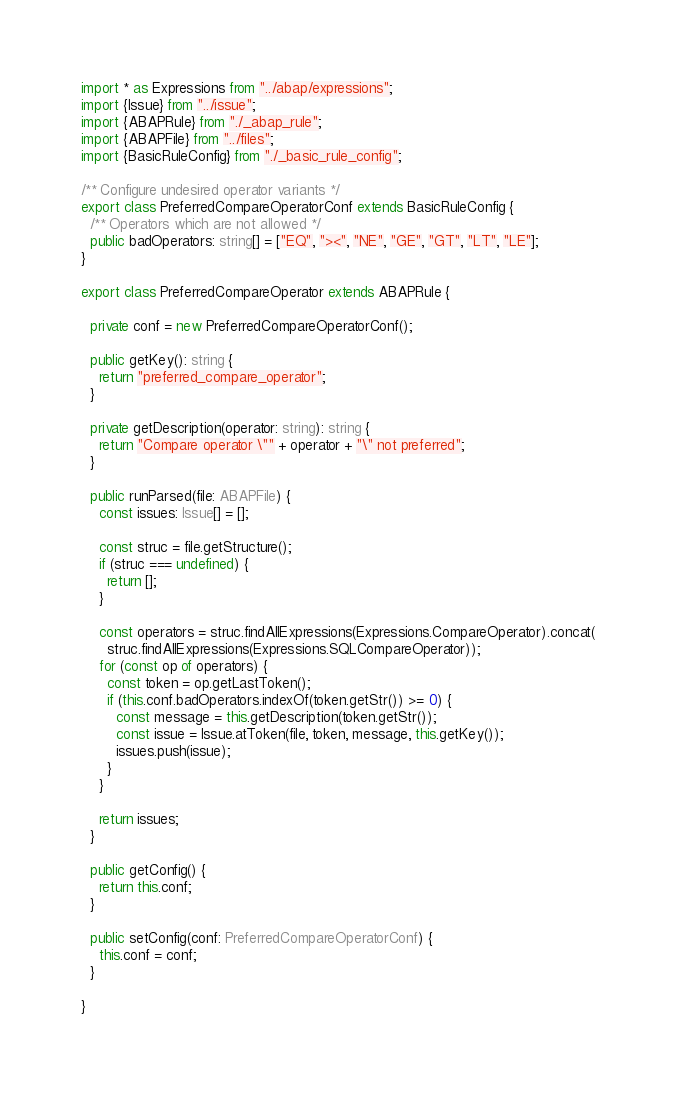Convert code to text. <code><loc_0><loc_0><loc_500><loc_500><_TypeScript_>import * as Expressions from "../abap/expressions";
import {Issue} from "../issue";
import {ABAPRule} from "./_abap_rule";
import {ABAPFile} from "../files";
import {BasicRuleConfig} from "./_basic_rule_config";

/** Configure undesired operator variants */
export class PreferredCompareOperatorConf extends BasicRuleConfig {
  /** Operators which are not allowed */
  public badOperators: string[] = ["EQ", "><", "NE", "GE", "GT", "LT", "LE"];
}

export class PreferredCompareOperator extends ABAPRule {

  private conf = new PreferredCompareOperatorConf();

  public getKey(): string {
    return "preferred_compare_operator";
  }

  private getDescription(operator: string): string {
    return "Compare operator \"" + operator + "\" not preferred";
  }

  public runParsed(file: ABAPFile) {
    const issues: Issue[] = [];

    const struc = file.getStructure();
    if (struc === undefined) {
      return [];
    }

    const operators = struc.findAllExpressions(Expressions.CompareOperator).concat(
      struc.findAllExpressions(Expressions.SQLCompareOperator));
    for (const op of operators) {
      const token = op.getLastToken();
      if (this.conf.badOperators.indexOf(token.getStr()) >= 0) {
        const message = this.getDescription(token.getStr());
        const issue = Issue.atToken(file, token, message, this.getKey());
        issues.push(issue);
      }
    }

    return issues;
  }

  public getConfig() {
    return this.conf;
  }

  public setConfig(conf: PreferredCompareOperatorConf) {
    this.conf = conf;
  }

}</code> 